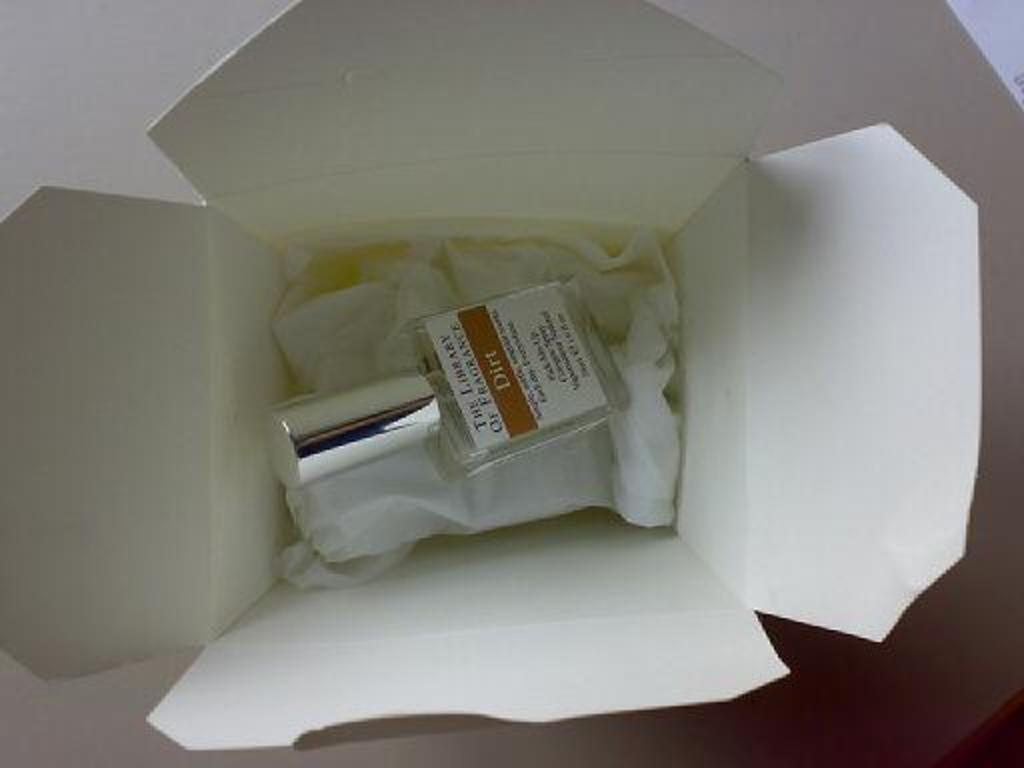<image>
Present a compact description of the photo's key features. A bottle of Dirt scented perfume is in a white Chinese takeout box. 